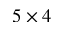<formula> <loc_0><loc_0><loc_500><loc_500>5 \times 4</formula> 